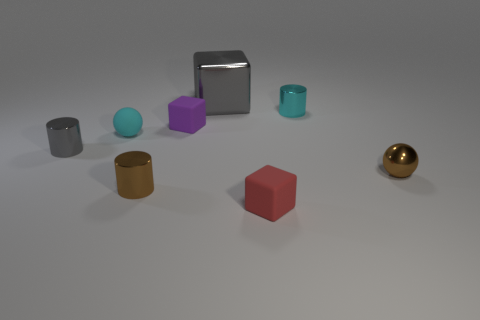Are there any tiny matte things that have the same color as the big shiny object?
Your answer should be very brief. No. Is the number of cyan cylinders less than the number of shiny cylinders?
Offer a terse response. Yes. How many things are either cyan blocks or gray metallic things to the left of the purple thing?
Make the answer very short. 1. Is there a gray cube made of the same material as the small gray thing?
Ensure brevity in your answer.  Yes. There is a red thing that is the same size as the cyan shiny cylinder; what is it made of?
Provide a short and direct response. Rubber. The ball to the left of the small sphere to the right of the rubber sphere is made of what material?
Provide a succinct answer. Rubber. There is a cyan thing that is in front of the purple matte block; is its shape the same as the small purple matte thing?
Your answer should be compact. No. What is the color of the tiny ball that is the same material as the small purple object?
Keep it short and to the point. Cyan. There is a small cyan thing left of the tiny brown cylinder; what material is it?
Your answer should be very brief. Rubber. There is a big object; does it have the same shape as the small purple rubber thing on the left side of the large metallic block?
Make the answer very short. Yes. 